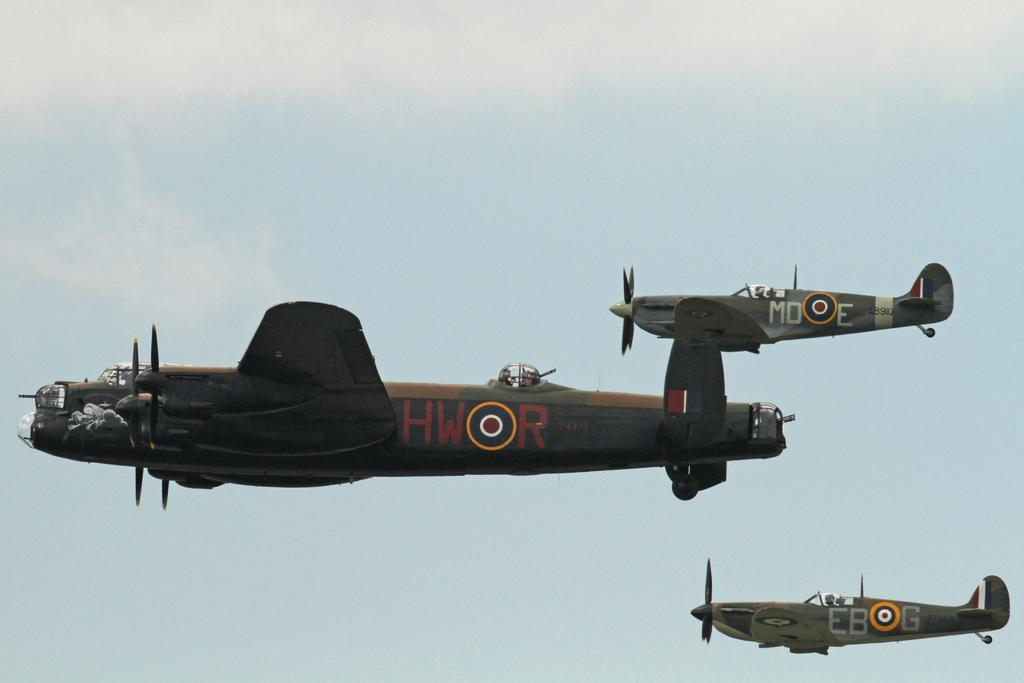Please provide a concise description of this image. In this image we can see airplanes flying in the sky. 